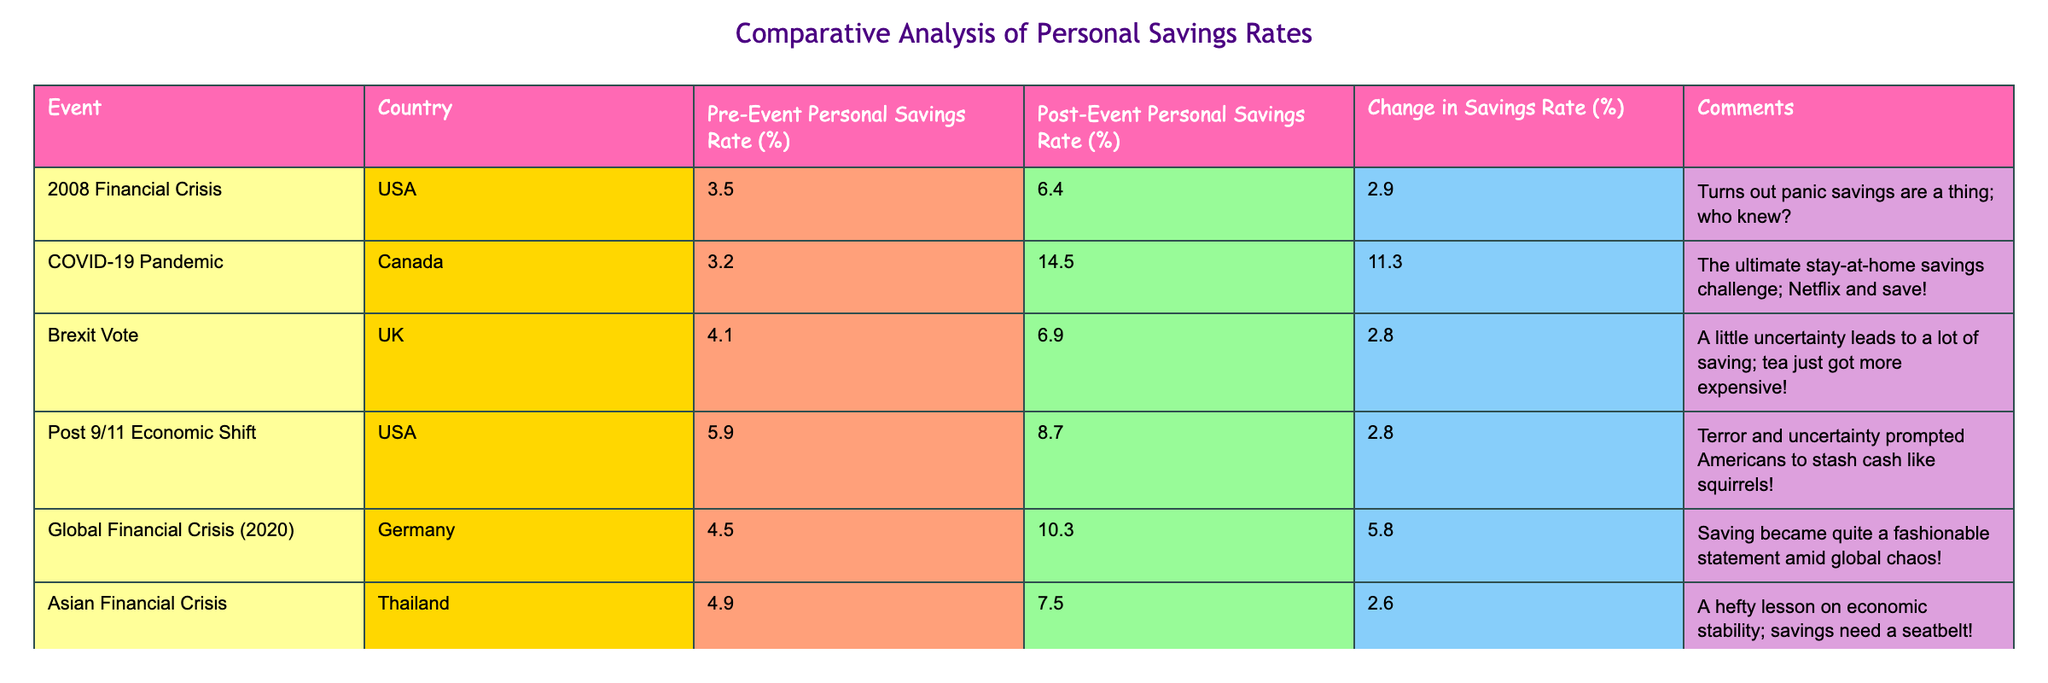What is the post-event personal savings rate in Canada after the COVID-19 pandemic? The table specifies the post-event savings rate of Canada post-COVID-19 as 14.5%.
Answer: 14.5% Which country experienced the highest percentage change in personal savings rate after a major economic event? Looking at the changes, Canada saw an increase of 11.3%, the highest among the countries listed.
Answer: Canada Did the personal savings rate in the USA increase after the 2008 Financial Crisis? Yes, the post-event rate was 6.4%, which is higher than the pre-event rate of 3.5%.
Answer: Yes What is the average change in savings rate for the countries listed in the table? The changes are 2.9, 11.3, 2.8, 2.8, 5.8, and 2.6. The total change is 28.2, and there are 6 data points, so the average is 28.2/6 = 4.7%.
Answer: 4.7% Which country's savings rate showed the least change and by how much? Thailand's savings rate changed by 2.6%, which is the smallest change compared to other countries listed.
Answer: 2.6% How did the savings rate in the UK change after the Brexit vote? The savings rate increased from 4.1% to 6.9%, reflecting a change of 2.8%.
Answer: 2.8% Is it true that every country listed in the table saw an increase in personal savings rates after the major economic events? Yes, all countries had higher post-event savings rates compared to their pre-event rates.
Answer: Yes Calculate the difference in the savings rate pre and post the financial crisis in Germany. The pre-event savings rate was 4.5% and the post-event rate was 10.3%, so the difference is 10.3 - 4.5 = 5.8%.
Answer: 5.8% Which economic event led to the largest increase in savings rate in a single country? Canada’s savings rate surged by 11.3% due to the COVID-19 pandemic, which is the largest increase in the table.
Answer: COVID-19 Pandemic If we exclude the USA, which country had the second highest post-event savings rate, and what was the rate? Canada had the highest post-event savings rate of 14.5% and after the USA at 6.4%, UK had 6.9% making it the second highest.
Answer: 6.9% 